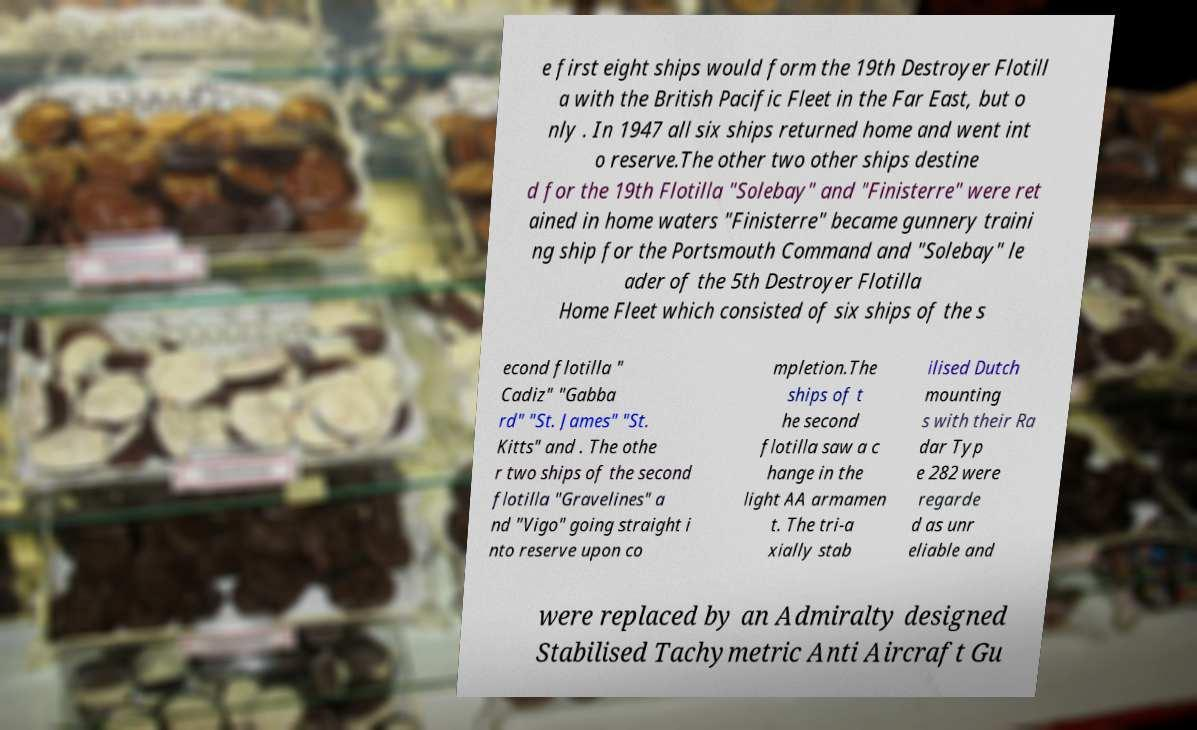Please identify and transcribe the text found in this image. e first eight ships would form the 19th Destroyer Flotill a with the British Pacific Fleet in the Far East, but o nly . In 1947 all six ships returned home and went int o reserve.The other two other ships destine d for the 19th Flotilla "Solebay" and "Finisterre" were ret ained in home waters "Finisterre" became gunnery traini ng ship for the Portsmouth Command and "Solebay" le ader of the 5th Destroyer Flotilla Home Fleet which consisted of six ships of the s econd flotilla " Cadiz" "Gabba rd" "St. James" "St. Kitts" and . The othe r two ships of the second flotilla "Gravelines" a nd "Vigo" going straight i nto reserve upon co mpletion.The ships of t he second flotilla saw a c hange in the light AA armamen t. The tri-a xially stab ilised Dutch mounting s with their Ra dar Typ e 282 were regarde d as unr eliable and were replaced by an Admiralty designed Stabilised Tachymetric Anti Aircraft Gu 